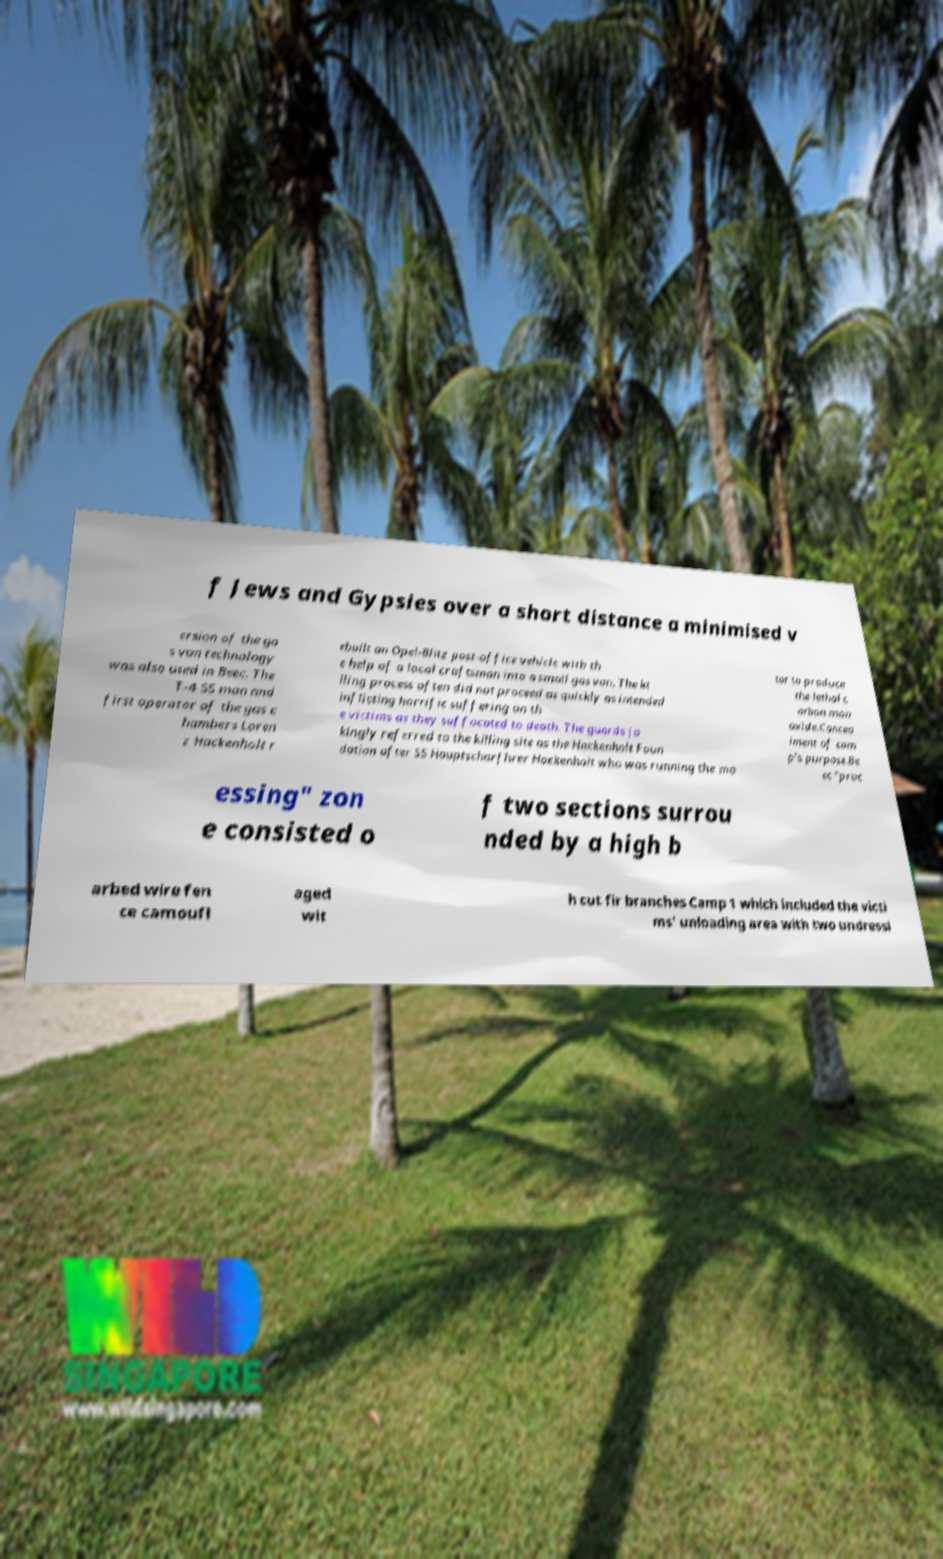Please identify and transcribe the text found in this image. f Jews and Gypsies over a short distance a minimised v ersion of the ga s van technology was also used in Beec. The T-4 SS man and first operator of the gas c hambers Loren z Hackenholt r ebuilt an Opel-Blitz post-office vehicle with th e help of a local craftsman into a small gas van. The ki lling process often did not proceed as quickly as intended inflicting horrific suffering on th e victims as they suffocated to death. The guards jo kingly referred to the killing site as the Hackenholt Foun dation after SS Hauptscharfhrer Hackenholt who was running the mo tor to produce the lethal c arbon mon oxide.Concea lment of cam p's purpose.Be ec "proc essing" zon e consisted o f two sections surrou nded by a high b arbed wire fen ce camoufl aged wit h cut fir branches Camp 1 which included the victi ms' unloading area with two undressi 